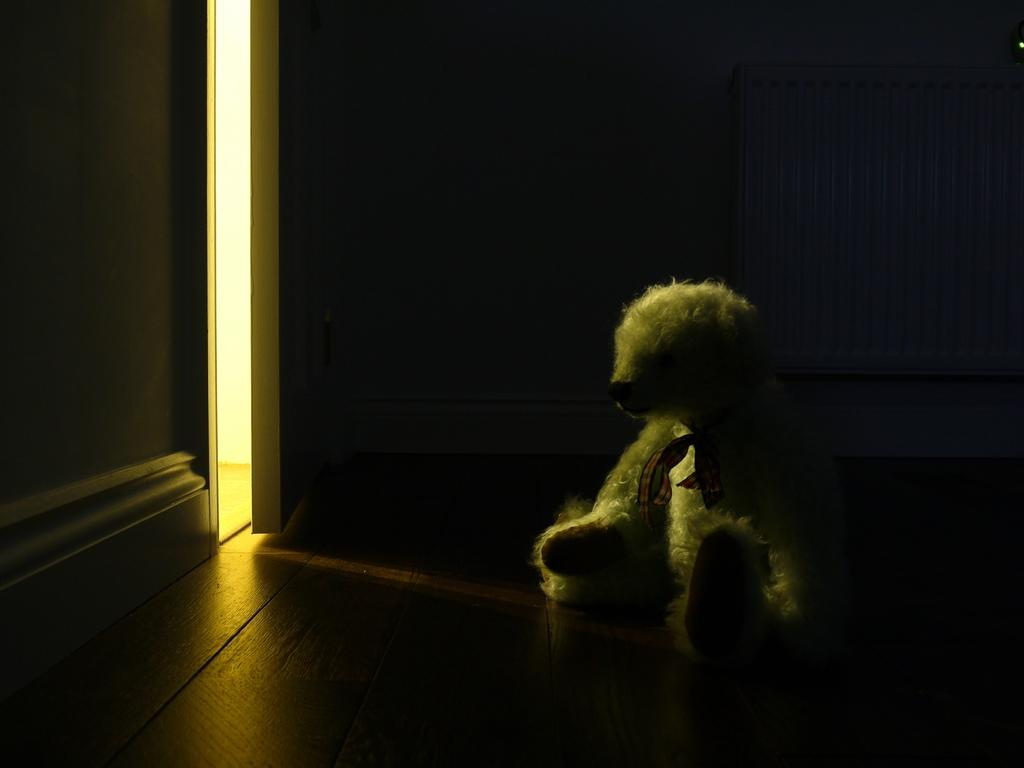What is the color of the doll in the image? The doll in the image is white. What is the doll placed on in the image? The doll is on the brown color floor. What is in front of the doll in the image? There is a wall in front of the doll. What is in front of the wall in the image? There is a door in front of the wall. How many girls are using the doll as a doctor in the image? There are no girls or doctors present in the image; it only features a doll on the floor. 